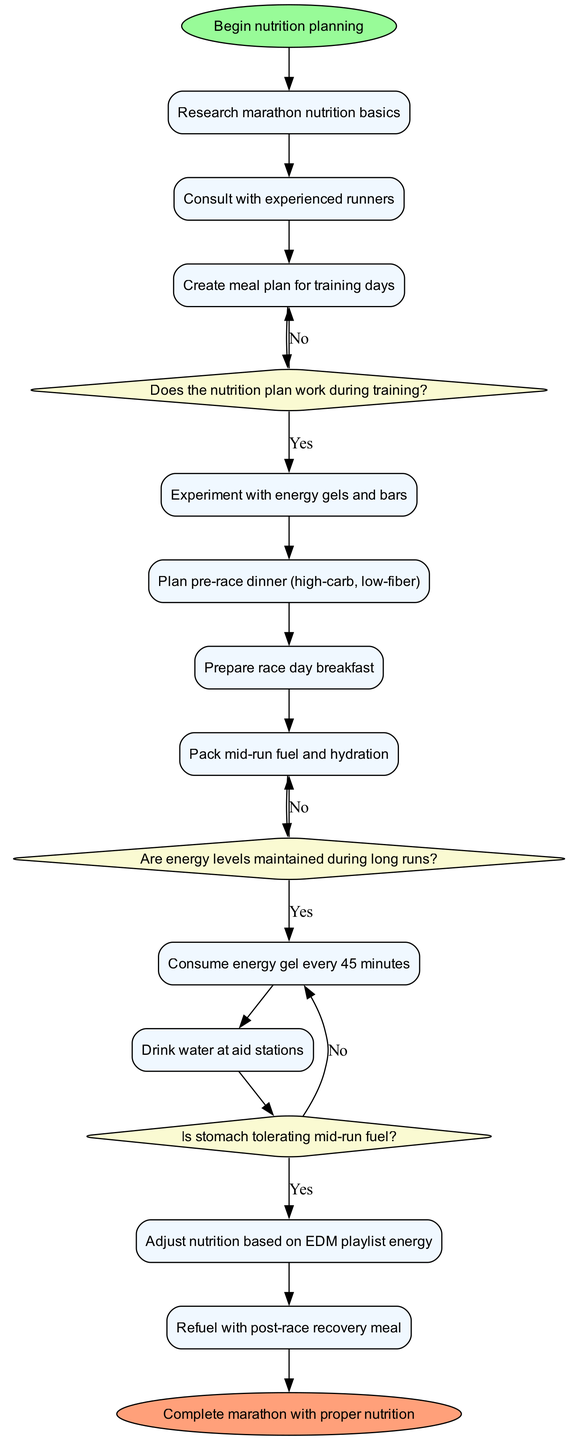What is the starting activity in the diagram? The diagram begins with the node labeled "Begin nutrition planning", which indicates the starting point of the activities.
Answer: Begin nutrition planning How many activities are listed in the diagram? By counting the activities defined within the diagram, there are a total of ten distinct activities.
Answer: 10 What is the final node in the diagram? The end node of the diagram is labeled "Complete marathon with proper nutrition", which signifies the goal of the entire process.
Answer: Complete marathon with proper nutrition What decision follows "Create meal plan for training days"? After "Create meal plan for training days", the next decision is "Does the nutrition plan work during training?", which determines the effectiveness of the meal plan.
Answer: Does the nutrition plan work during training? What happens if the nutrition plan does not work during training? If the nutrition plan does not work during training, the flow indicates that it returns to the activity "Create meal plan for training days" to re-evaluate and make adjustments.
Answer: Create meal plan for training days Which activity requires experimenting with energy gels and bars? The activity "Experiment with energy gels and bars" is explicitly listed among the other activities in the diagram before planning the pre-race dinner.
Answer: Experiment with energy gels and bars How often should the energy gel be consumed during the marathon? The diagram specifies that energy gel should be consumed every 45 minutes during the race as part of the mid-run fueling strategy.
Answer: Every 45 minutes What is the decision concerning stomach tolerance? The decision "Is stomach tolerating mid-run fuel?" follows the activity of drinking water at aid stations and determines whether the mid-run fuel needs to be adjusted based on discomfort.
Answer: Is stomach tolerating mid-run fuel? What is the activity described after "Consume energy gel every 45 minutes"? The activity that follows after consuming energy gel every 45 minutes is "Drink water at aid stations", indicating the need for hydration alongside energy consumption.
Answer: Drink water at aid stations 